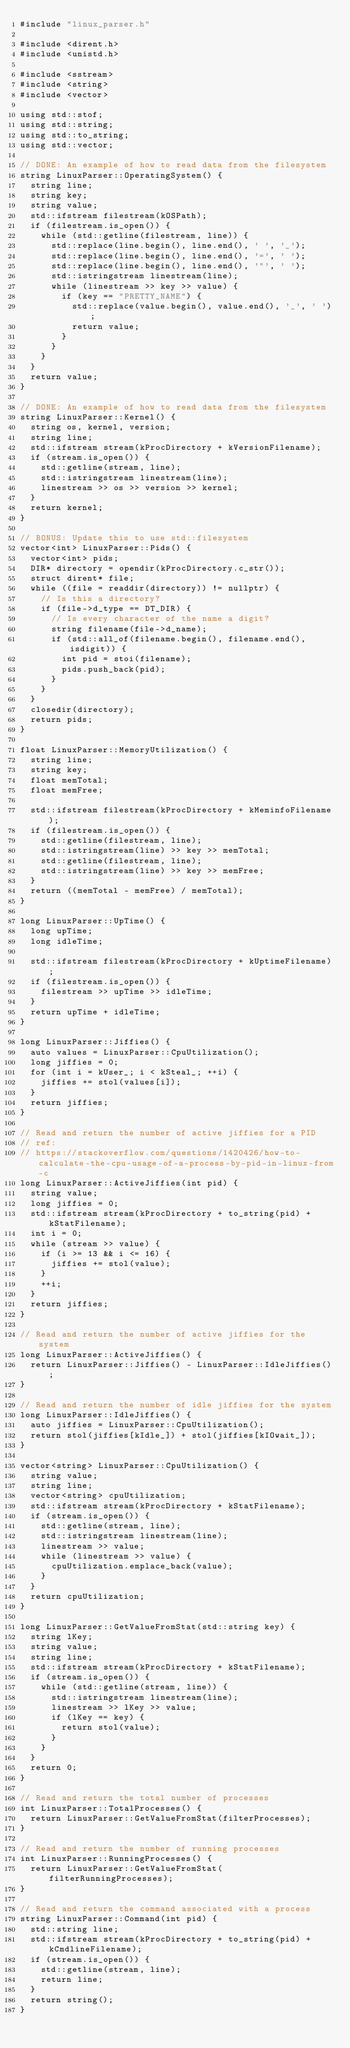Convert code to text. <code><loc_0><loc_0><loc_500><loc_500><_C++_>#include "linux_parser.h"

#include <dirent.h>
#include <unistd.h>

#include <sstream>
#include <string>
#include <vector>

using std::stof;
using std::string;
using std::to_string;
using std::vector;

// DONE: An example of how to read data from the filesystem
string LinuxParser::OperatingSystem() {
  string line;
  string key;
  string value;
  std::ifstream filestream(kOSPath);
  if (filestream.is_open()) {
    while (std::getline(filestream, line)) {
      std::replace(line.begin(), line.end(), ' ', '_');
      std::replace(line.begin(), line.end(), '=', ' ');
      std::replace(line.begin(), line.end(), '"', ' ');
      std::istringstream linestream(line);
      while (linestream >> key >> value) {
        if (key == "PRETTY_NAME") {
          std::replace(value.begin(), value.end(), '_', ' ');
          return value;
        }
      }
    }
  }
  return value;
}

// DONE: An example of how to read data from the filesystem
string LinuxParser::Kernel() {
  string os, kernel, version;
  string line;
  std::ifstream stream(kProcDirectory + kVersionFilename);
  if (stream.is_open()) {
    std::getline(stream, line);
    std::istringstream linestream(line);
    linestream >> os >> version >> kernel;
  }
  return kernel;
}

// BONUS: Update this to use std::filesystem
vector<int> LinuxParser::Pids() {
  vector<int> pids;
  DIR* directory = opendir(kProcDirectory.c_str());
  struct dirent* file;
  while ((file = readdir(directory)) != nullptr) {
    // Is this a directory?
    if (file->d_type == DT_DIR) {
      // Is every character of the name a digit?
      string filename(file->d_name);
      if (std::all_of(filename.begin(), filename.end(), isdigit)) {
        int pid = stoi(filename);
        pids.push_back(pid);
      }
    }
  }
  closedir(directory);
  return pids;
}

float LinuxParser::MemoryUtilization() {
  string line;
  string key;
  float memTotal;
  float memFree;

  std::ifstream filestream(kProcDirectory + kMeminfoFilename);
  if (filestream.is_open()) {
    std::getline(filestream, line);
    std::istringstream(line) >> key >> memTotal;
    std::getline(filestream, line);
    std::istringstream(line) >> key >> memFree;
  }
  return ((memTotal - memFree) / memTotal);
}

long LinuxParser::UpTime() {
  long upTime;
  long idleTime;

  std::ifstream filestream(kProcDirectory + kUptimeFilename);
  if (filestream.is_open()) {
    filestream >> upTime >> idleTime;
  }
  return upTime + idleTime;
}

long LinuxParser::Jiffies() {
  auto values = LinuxParser::CpuUtilization();
  long jiffies = 0;
  for (int i = kUser_; i < kSteal_; ++i) {
    jiffies += stol(values[i]);
  }
  return jiffies;
}

// Read and return the number of active jiffies for a PID
// ref:
// https://stackoverflow.com/questions/1420426/how-to-calculate-the-cpu-usage-of-a-process-by-pid-in-linux-from-c
long LinuxParser::ActiveJiffies(int pid) {
  string value;
  long jiffies = 0;
  std::ifstream stream(kProcDirectory + to_string(pid) + kStatFilename);
  int i = 0;
  while (stream >> value) {
    if (i >= 13 && i <= 16) {
      jiffies += stol(value);
    }
    ++i;
  }
  return jiffies;
}

// Read and return the number of active jiffies for the system
long LinuxParser::ActiveJiffies() {
  return LinuxParser::Jiffies() - LinuxParser::IdleJiffies();
}

// Read and return the number of idle jiffies for the system
long LinuxParser::IdleJiffies() {
  auto jiffies = LinuxParser::CpuUtilization();
  return stol(jiffies[kIdle_]) + stol(jiffies[kIOwait_]);
}

vector<string> LinuxParser::CpuUtilization() {
  string value;
  string line;
  vector<string> cpuUtilization;
  std::ifstream stream(kProcDirectory + kStatFilename);
  if (stream.is_open()) {
    std::getline(stream, line);
    std::istringstream linestream(line);
    linestream >> value;
    while (linestream >> value) {
      cpuUtilization.emplace_back(value);
    }
  }
  return cpuUtilization;
}

long LinuxParser::GetValueFromStat(std::string key) {
  string lKey;
  string value;
  string line;
  std::ifstream stream(kProcDirectory + kStatFilename);
  if (stream.is_open()) {
    while (std::getline(stream, line)) {
      std::istringstream linestream(line);
      linestream >> lKey >> value;
      if (lKey == key) {
        return stol(value);
      }
    }
  }
  return 0;
}

// Read and return the total number of processes
int LinuxParser::TotalProcesses() {
  return LinuxParser::GetValueFromStat(filterProcesses);
}

// Read and return the number of running processes
int LinuxParser::RunningProcesses() {
  return LinuxParser::GetValueFromStat(filterRunningProcesses);
}

// Read and return the command associated with a process
string LinuxParser::Command(int pid) {
  std::string line;
  std::ifstream stream(kProcDirectory + to_string(pid) + kCmdlineFilename);
  if (stream.is_open()) {
    std::getline(stream, line);
    return line;
  }
  return string();
}
</code> 